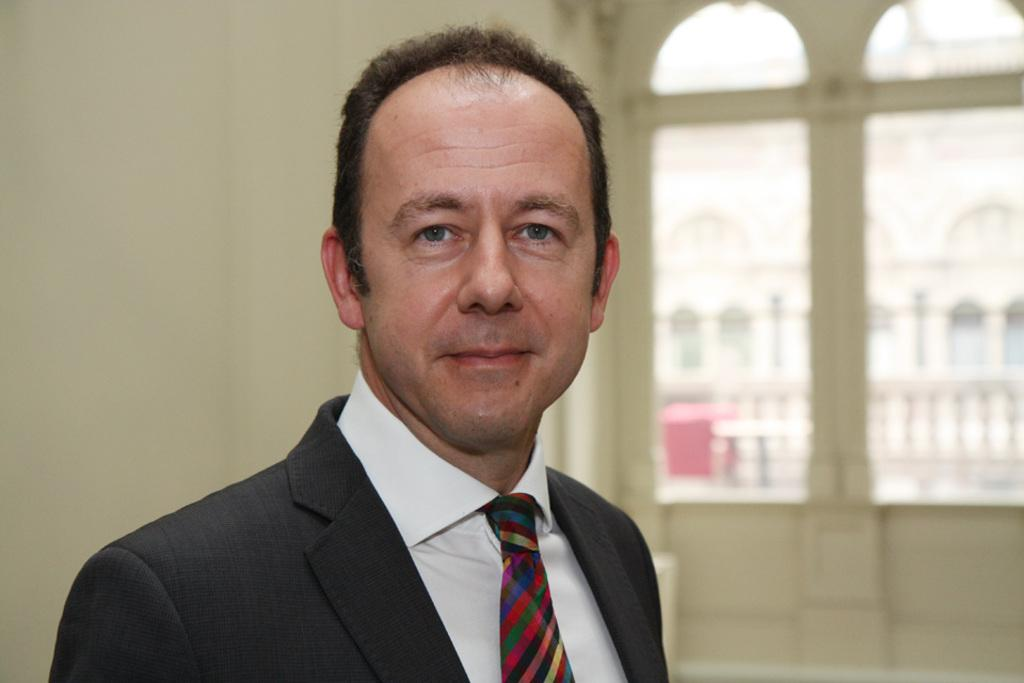What is the main subject in the foreground of the image? There is a person in the foreground of the image. On which side of the image is the person located? The person is on the left side. What architectural features can be seen in the image? There are windows and a wall visible in the image. What type of bread is being served for lunch in the image? There is no lunch or bread present in the image; it only features a person on the left side with windows and a wall in the background. 